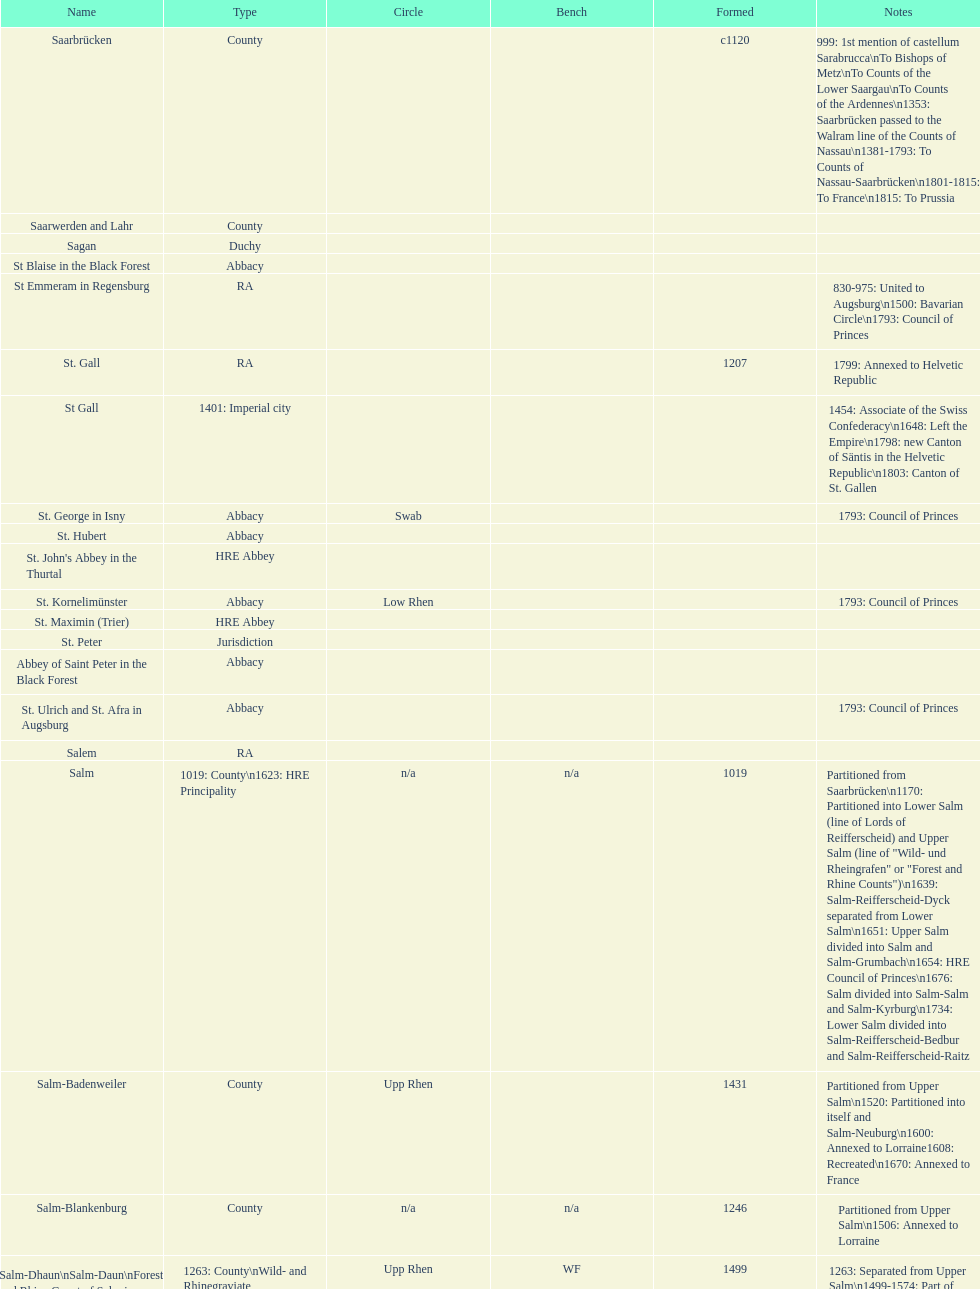In how many states was the type similar to that of stühlingen? 3. 